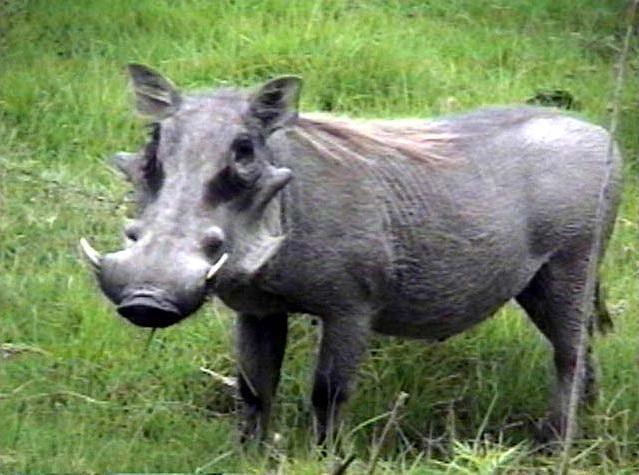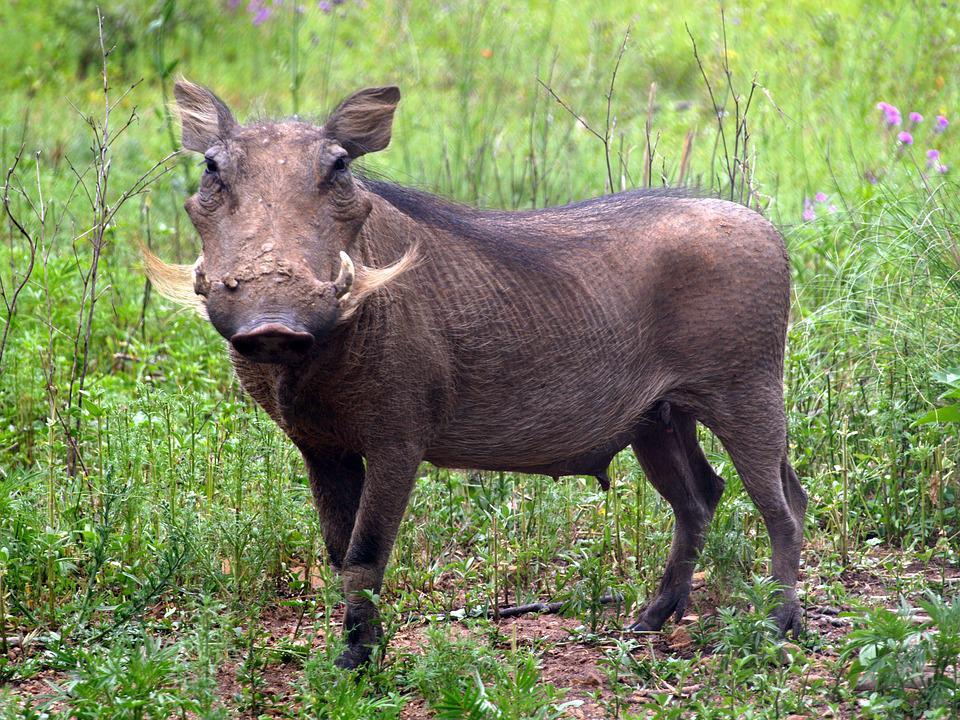The first image is the image on the left, the second image is the image on the right. For the images shown, is this caption "the hog on the right image is facing left." true? Answer yes or no. Yes. 